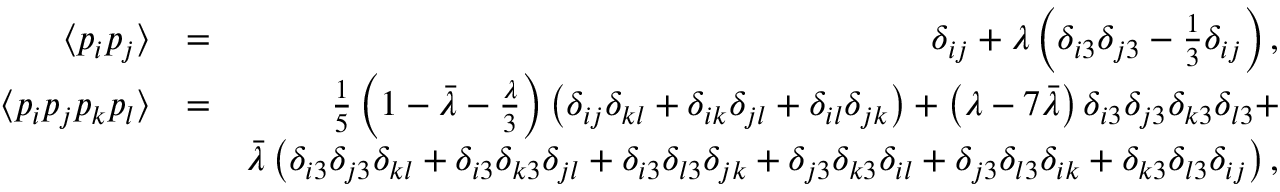<formula> <loc_0><loc_0><loc_500><loc_500>\begin{array} { r l r } { \langle p _ { i } p _ { j } \rangle } & { = } & { \delta _ { i j } + \lambda \left ( \delta _ { i 3 } \delta _ { j 3 } - \frac { 1 } { 3 } \delta _ { i j } \right ) , } \\ { \langle p _ { i } p _ { j } p _ { k } p _ { l } \rangle } & { = } & { \frac { 1 } { 5 } \left ( 1 - \bar { \lambda } - \frac { \lambda } { 3 } \right ) \left ( \delta _ { i j } \delta _ { k l } + \delta _ { i k } \delta _ { j l } + \delta _ { i l } \delta _ { j k } \right ) + \left ( \lambda - 7 \bar { \lambda } \right ) \delta _ { i 3 } \delta _ { j 3 } \delta _ { k 3 } \delta _ { l 3 } + } \\ & { \bar { \lambda } \left ( \delta _ { i 3 } \delta _ { j 3 } \delta _ { k l } + \delta _ { i 3 } \delta _ { k 3 } \delta _ { j l } + \delta _ { i 3 } \delta _ { l 3 } \delta _ { j k } + \delta _ { j 3 } \delta _ { k 3 } \delta _ { i l } + \delta _ { j 3 } \delta _ { l 3 } \delta _ { i k } + \delta _ { k 3 } \delta _ { l 3 } \delta _ { i j } \right ) , } \end{array}</formula> 